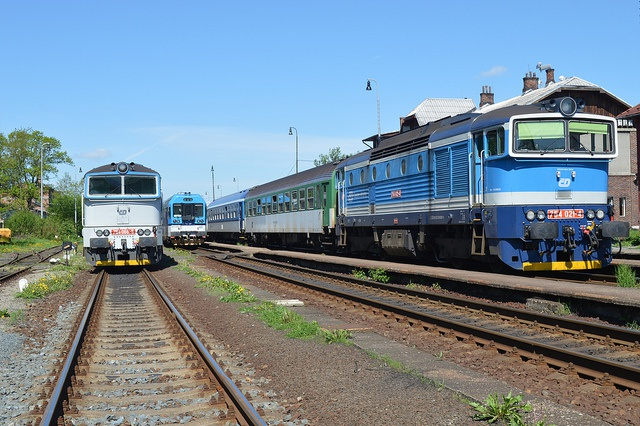Describe the objects in this image and their specific colors. I can see train in lightblue, black, gray, blue, and darkgray tones, train in lightblue, lightgray, black, gray, and darkgray tones, and train in lightblue, black, gray, and white tones in this image. 